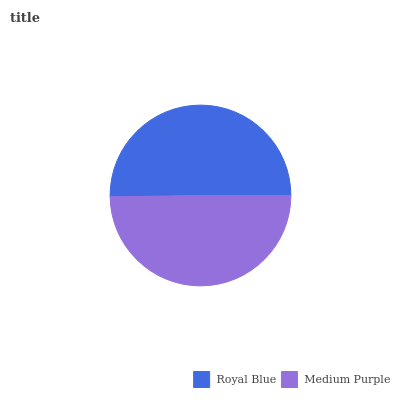Is Medium Purple the minimum?
Answer yes or no. Yes. Is Royal Blue the maximum?
Answer yes or no. Yes. Is Medium Purple the maximum?
Answer yes or no. No. Is Royal Blue greater than Medium Purple?
Answer yes or no. Yes. Is Medium Purple less than Royal Blue?
Answer yes or no. Yes. Is Medium Purple greater than Royal Blue?
Answer yes or no. No. Is Royal Blue less than Medium Purple?
Answer yes or no. No. Is Royal Blue the high median?
Answer yes or no. Yes. Is Medium Purple the low median?
Answer yes or no. Yes. Is Medium Purple the high median?
Answer yes or no. No. Is Royal Blue the low median?
Answer yes or no. No. 